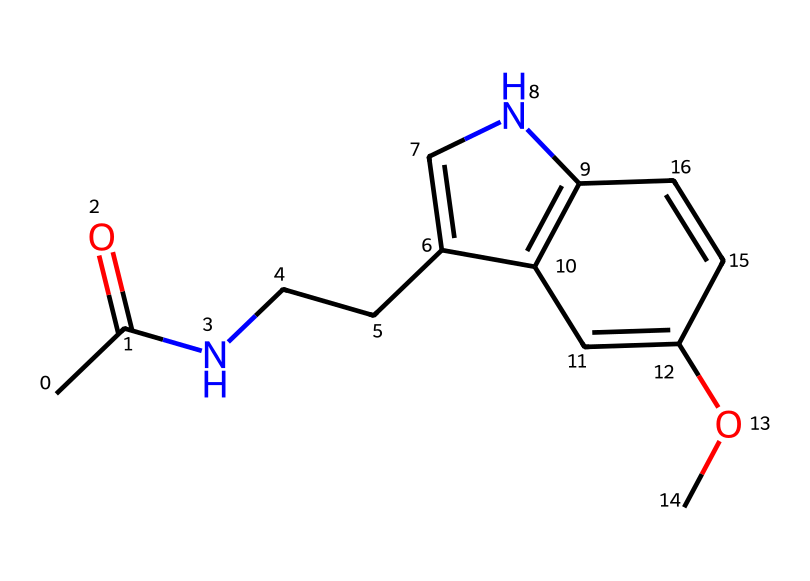What is the primary functional group in melatonin? The chemical structure contains an amide group (indicated by the carbonyl group adjacent to a nitrogen atom) and an ether (the -O- connected to a carbon). However, when asked for the primary functional group, the amide is more significant in terms of biological activity regarding melatonin's function.
Answer: amide How many carbon atoms are in the melatonin structure? The structural formula shows a total of 11 carbon atoms (counting the carbons in the chain and rings in the structure). Each carbon atom in the SMILES representation can be deduced to confirm the total.
Answer: 11 What type of hybridization is present in the nitrogen atom of melatonin? Examining the nitrogen atom, it is bonded to one carbon atom and the hydrogen, indicating it is likely trigonal planar which suggests sp2 hybridization for bonding characteristics.
Answer: sp2 Which part of the molecule indicates its aliphatic nature? The longest continuous carbon chain in the structure without any aromatic rings directly reflects the aliphatic classification, along with the presence of the C-C and C-N bonds.
Answer: carbon chain How many nitrogen atoms are present in melatonin? In the SMILES representation, there are two nitrogen atoms, one in the amide group and one within the ring structure, which can be counted from the representation.
Answer: 2 What is the total number of bonds between carbon and nitrogen in melatonin? Looking at the structure, one direct bond (in the amide) and additional bonds can be identified among carbon and nitrogen, resulting in total both that contributes bonding interactions; thus, there are 3 C-N bonds.
Answer: 3 What does the presence of the methoxy group (–OCH3) indicate about melatonin's properties? The methoxy group, as an ether, indicates increased lipophilicity which can impact its ability to cross biological membranes, contributing to its biological activity in regulating sleep patterns.
Answer: lipophilic 